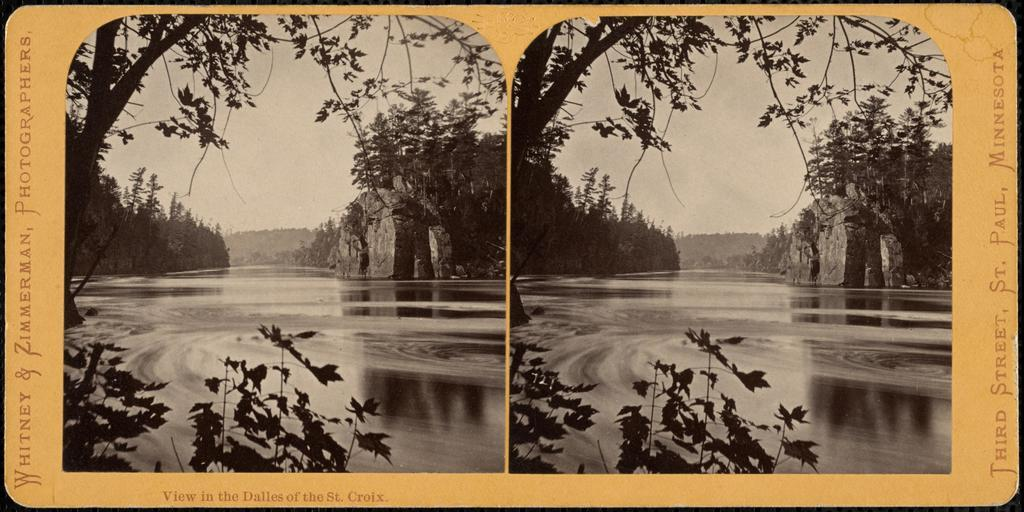What type of artwork is the image? The image is a collage. What natural elements can be seen in the collage? There are trees and water visible in the image. What geological feature is present in the collage? There is a rock in the image. Can you tell me how many women are sitting on the rock in the image? There are no women present in the image; it features a collage with trees, water, and a rock. What type of plants are growing on the rock in the image? There are no plants growing on the rock in the image; it is a geological feature without any vegetation. 